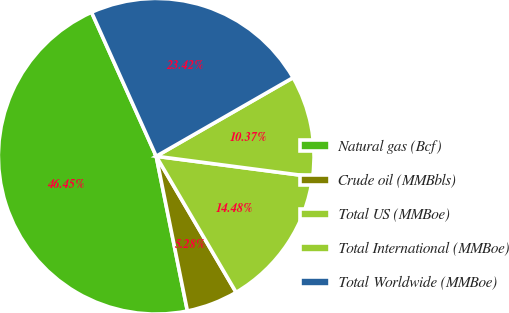<chart> <loc_0><loc_0><loc_500><loc_500><pie_chart><fcel>Natural gas (Bcf)<fcel>Crude oil (MMBbls)<fcel>Total US (MMBoe)<fcel>Total International (MMBoe)<fcel>Total Worldwide (MMBoe)<nl><fcel>46.45%<fcel>5.28%<fcel>14.48%<fcel>10.37%<fcel>23.42%<nl></chart> 